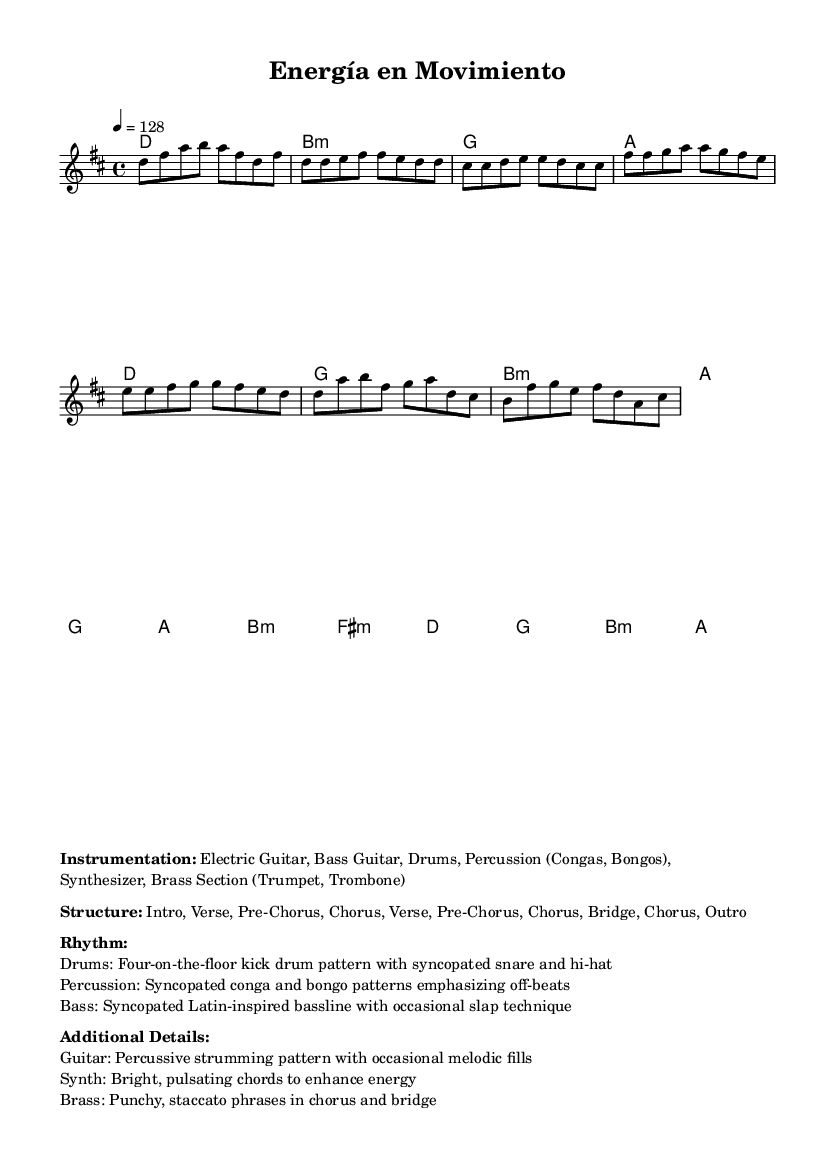What is the key signature of this music? The key signature is D major, which has two sharps (F# and C#). This is indicated by the key signature at the beginning of the staff.
Answer: D major What is the time signature of the piece? The time signature is 4/4, which is shown at the beginning of the music. This indicates that there are four beats per measure, with the quarter note getting the beat.
Answer: 4/4 What is the tempo marking for this music? The tempo marking is indicated as "4 = 128," which means there are 128 beats per minute, giving it a fast, lively feel suitable for workouts.
Answer: 128 How many sections are there in the structure of the piece? The structure provided mentions "Intro, Verse, Pre-Chorus, Chorus, Verse, Pre-Chorus, Chorus, Bridge, Chorus, Outro," which totals 10 sections.
Answer: 10 What type of drum pattern is used? The drums feature a "four-on-the-floor" kick drum pattern, which is typical for dance and upbeat music, providing a steady rhythmic drive.
Answer: Four-on-the-floor What instruments are highlighted in the instrumentation? The instrumentation includes Electric Guitar, Bass Guitar, Drums, Percussion (Congas, Bongos), Synthesizer, and Brass Section (Trumpet, Trombone), which collectively create a vibrant sound.
Answer: Electric Guitar, Bass Guitar, Drums, Congas, Bongos, Synthesizer, Brass Section What rhythmic style does the bass follow? The bass follows a "syncopated Latin-inspired bassline with occasional slap technique," providing a lively and energetic feel characteristic of Latin-pop fusion music.
Answer: Syncopated Latin-inspired bassline 